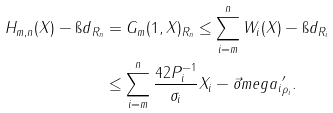Convert formula to latex. <formula><loc_0><loc_0><loc_500><loc_500>\| H _ { m , n } ( X ) - \i d \| _ { R _ { n } } & = \| G _ { m } ( 1 , X ) \| _ { R _ { n } } \leq \sum _ { i = m } ^ { n } \| W _ { i } ( X ) - \i d \| _ { R _ { i } } \\ & \leq \sum _ { i = m } ^ { n } \frac { 4 2 \| P _ { i } ^ { - 1 } \| } { \sigma _ { i } } \| X _ { i } - \vec { o } m e g a _ { i } \| ^ { \prime } _ { \rho _ { i } } .</formula> 